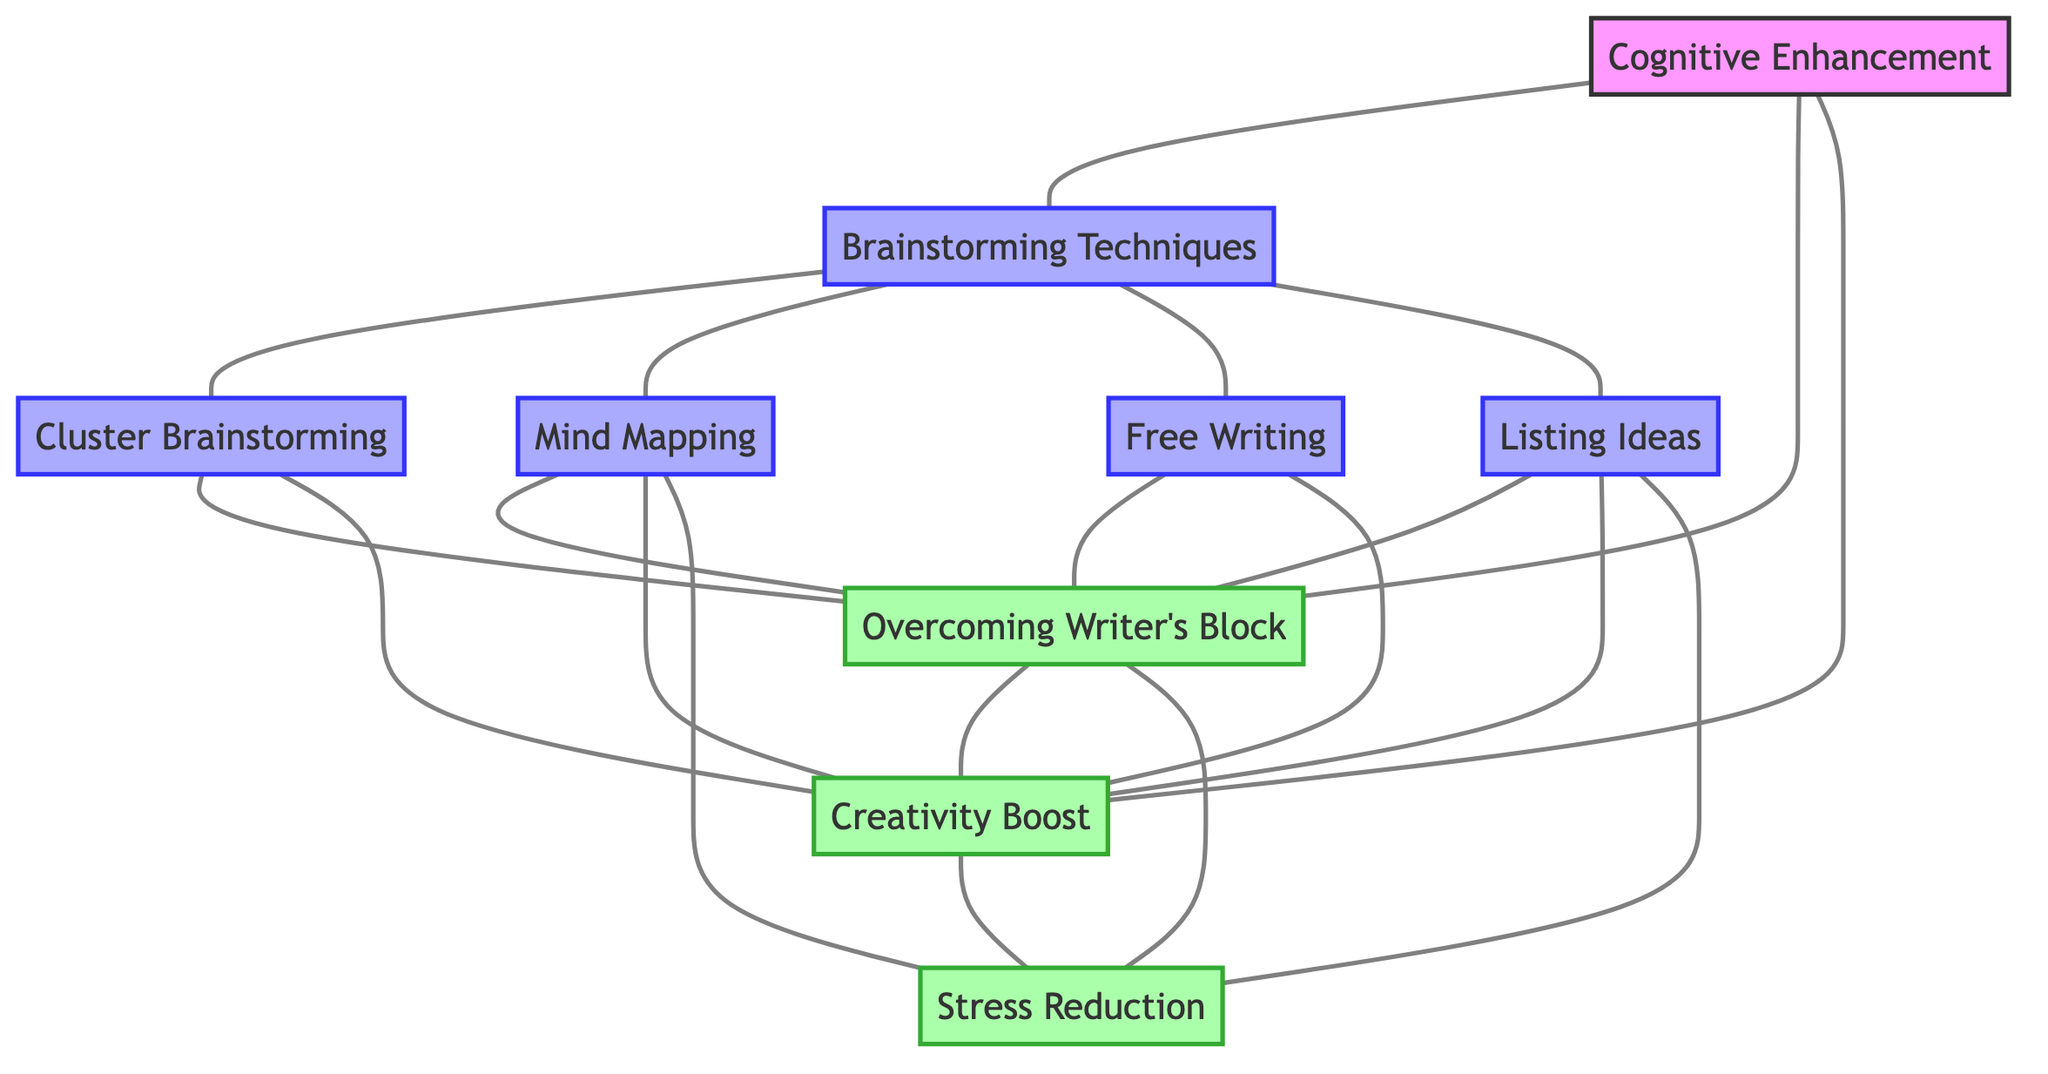What are the total number of nodes in the diagram? To find the total number of nodes, we count each distinct node listed in the "nodes" section. There are 9 nodes: Brainstorming Techniques, Cluster Brainstorming, Mind Mapping, Free Writing, Listing Ideas, Cognitive Enhancement, Overcoming Writer's Block, Creativity Boost, and Stress Reduction.
Answer: 9 Which brainstorming technique is directly connected to stress reduction? We examine the edges originating from "Mind Mapping", "Listing Ideas", and "Overcoming Writer's Block" to find a direct connection to "Stress Reduction". The nodes directly connected to "Stress Reduction" are "Mind Mapping", "Listing Ideas", and "Overcoming Writer's Block". Therefore, "Mind Mapping" and "Listing Ideas" are connected to "Stress Reduction".
Answer: Mind Mapping, Listing Ideas How many edges are connected to "Cognitive Enhancement"? We check the edges connected to the node "Cognitive Enhancement". It connects to three nodes: "Brainstorming Techniques", "Overcoming Writer's Block", and "Creativity Boost". Therefore, there are three edges connected to "Cognitive Enhancement".
Answer: 3 Which technique connects to both "Creativity Boost" and "Overcoming Writer's Block"? By observing the edges from each brainstorming technique, we find that "Cluster Brainstorming", "Mind Mapping", and "Free Writing" all lead to "Creativity Boost" and "Overcoming Writer's Block". Therefore, the techniques are "Cluster Brainstorming", "Mind Mapping", and "Free Writing".
Answer: Cluster Brainstorming, Mind Mapping, Free Writing What is the relationship between "Overcoming Writer's Block" and "Creativity Boost"? "Overcoming Writer's Block" has edges leading to "Creativity Boost", which indicates a direct relationship where overcoming writer's block likely leads to a boost in creativity. This relationship can be identified through the edges connecting them in the diagram.
Answer: Direct relationship 